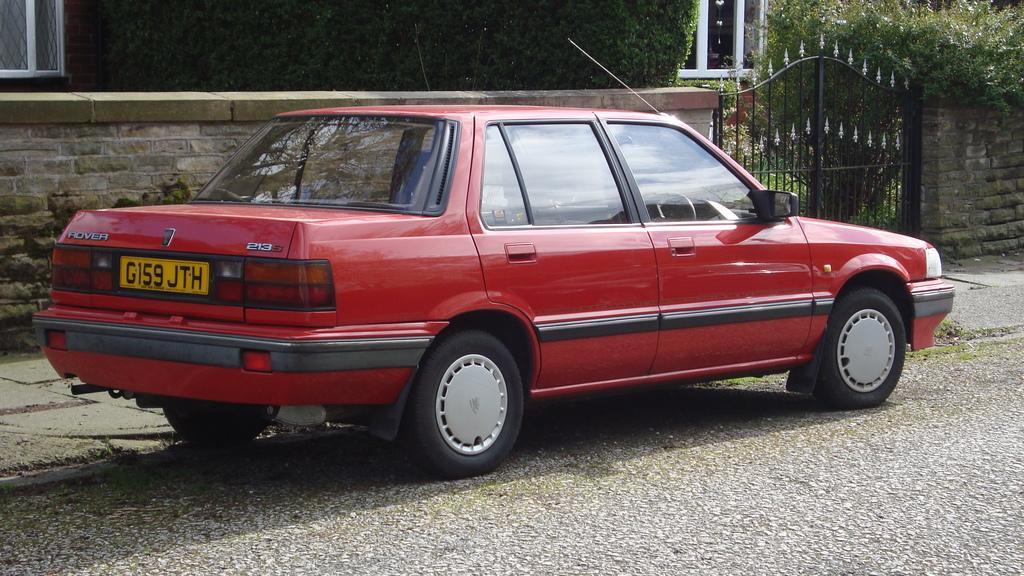How would you summarize this image in a sentence or two? There is a road. On the side of the road there is a car. Near to the car there is sidewalk. Also there are walls and gate. In the back there are trees and building with windows. 